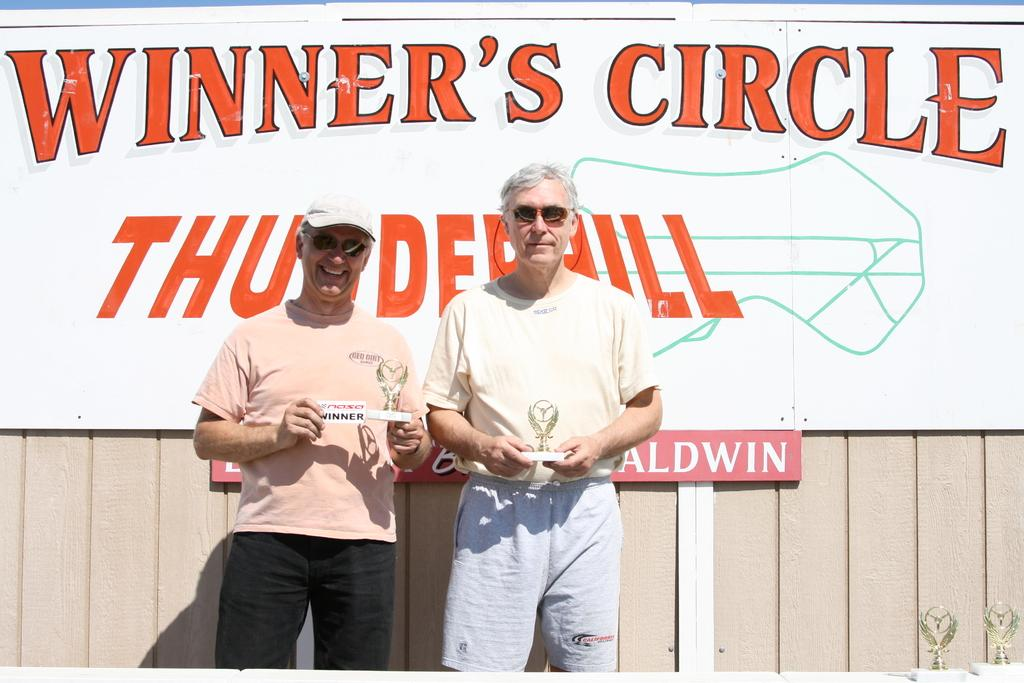How many people are present in the image? There are two persons in the image. What are the two persons doing in the image? The two persons are holding an object. What can be seen in the background of the image? There is a board with text written on it in the background of the image. How many cats are visible in the image? There are no cats present in the image. What type of land can be seen in the image? The image does not depict any land; it features two persons holding an object and a board with text in the background. 